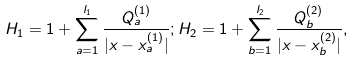<formula> <loc_0><loc_0><loc_500><loc_500>H _ { 1 } = 1 + \sum _ { a = 1 } ^ { l _ { 1 } } \frac { Q ^ { ( 1 ) } _ { a } } { | x - x ^ { ( 1 ) } _ { a } | } ; H _ { 2 } = 1 + \sum _ { b = 1 } ^ { l _ { 2 } } \frac { Q ^ { ( 2 ) } _ { b } } { | x - x ^ { ( 2 ) } _ { b } | } ,</formula> 